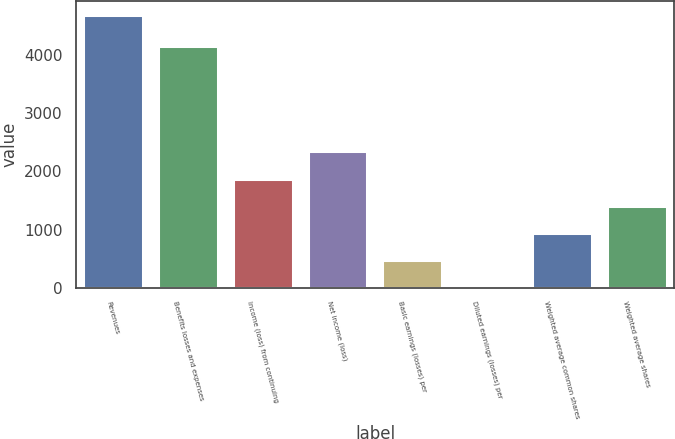Convert chart. <chart><loc_0><loc_0><loc_500><loc_500><bar_chart><fcel>Revenues<fcel>Benefits losses and expenses<fcel>Income (loss) from continuing<fcel>Net income (loss)<fcel>Basic earnings (losses) per<fcel>Diluted earnings (losses) per<fcel>Weighted average common shares<fcel>Weighted average shares<nl><fcel>4695<fcel>4167<fcel>1878.68<fcel>2348.07<fcel>470.51<fcel>1.12<fcel>939.9<fcel>1409.29<nl></chart> 